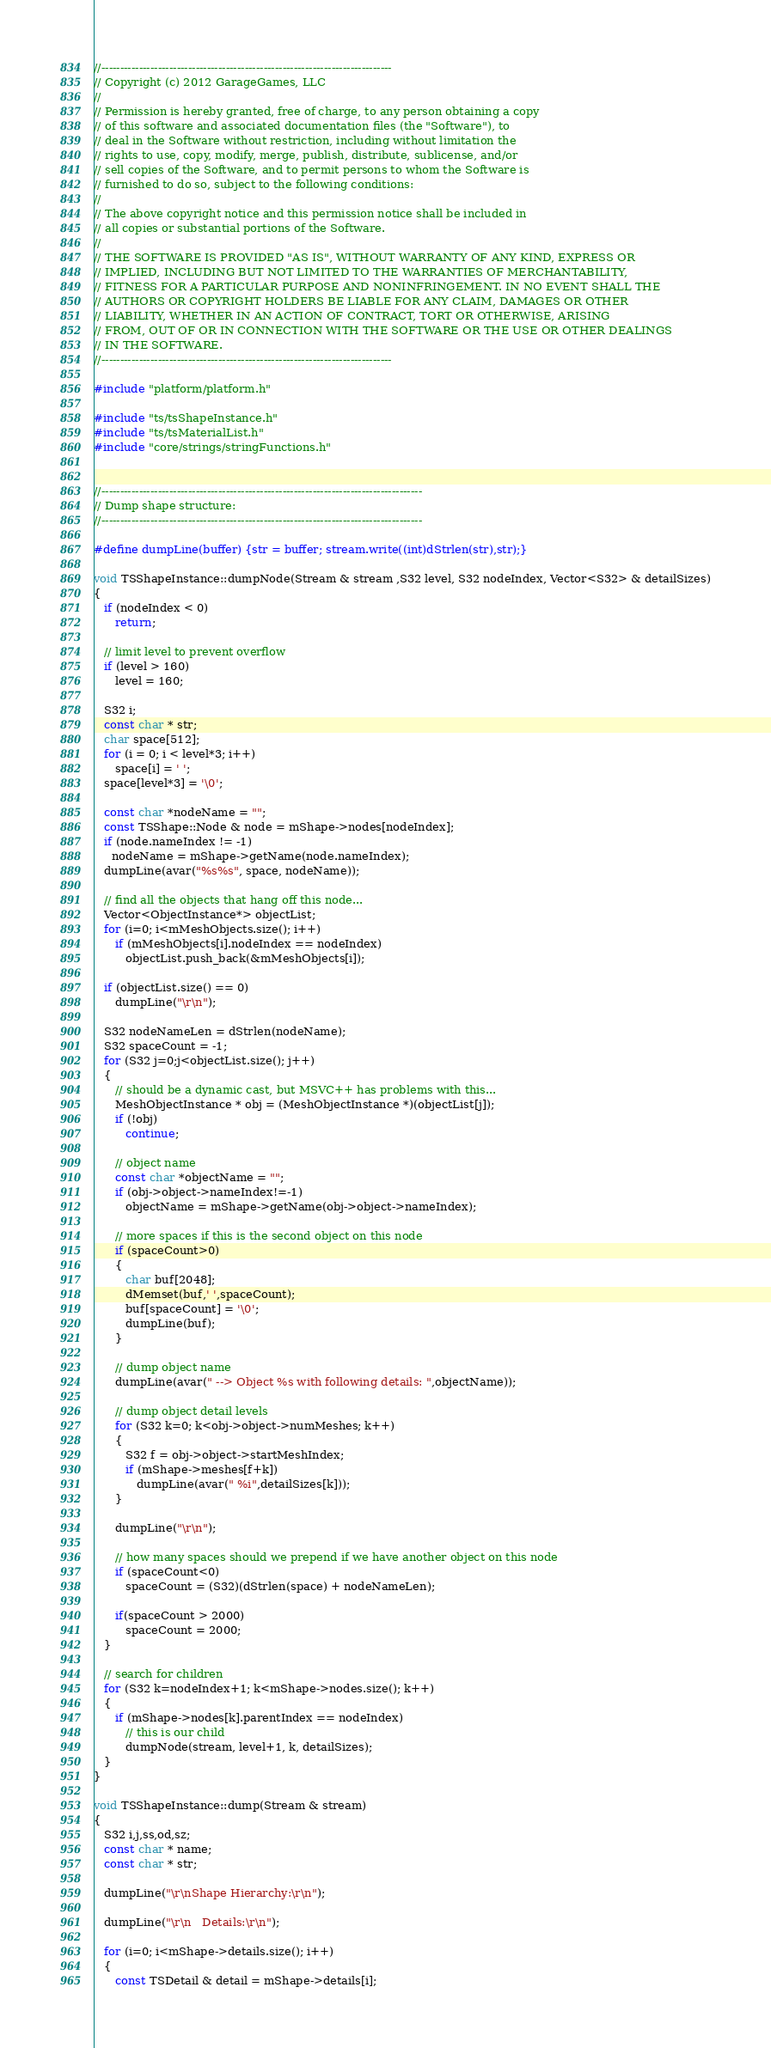<code> <loc_0><loc_0><loc_500><loc_500><_C++_>//-----------------------------------------------------------------------------
// Copyright (c) 2012 GarageGames, LLC
//
// Permission is hereby granted, free of charge, to any person obtaining a copy
// of this software and associated documentation files (the "Software"), to
// deal in the Software without restriction, including without limitation the
// rights to use, copy, modify, merge, publish, distribute, sublicense, and/or
// sell copies of the Software, and to permit persons to whom the Software is
// furnished to do so, subject to the following conditions:
//
// The above copyright notice and this permission notice shall be included in
// all copies or substantial portions of the Software.
//
// THE SOFTWARE IS PROVIDED "AS IS", WITHOUT WARRANTY OF ANY KIND, EXPRESS OR
// IMPLIED, INCLUDING BUT NOT LIMITED TO THE WARRANTIES OF MERCHANTABILITY,
// FITNESS FOR A PARTICULAR PURPOSE AND NONINFRINGEMENT. IN NO EVENT SHALL THE
// AUTHORS OR COPYRIGHT HOLDERS BE LIABLE FOR ANY CLAIM, DAMAGES OR OTHER
// LIABILITY, WHETHER IN AN ACTION OF CONTRACT, TORT OR OTHERWISE, ARISING
// FROM, OUT OF OR IN CONNECTION WITH THE SOFTWARE OR THE USE OR OTHER DEALINGS
// IN THE SOFTWARE.
//-----------------------------------------------------------------------------

#include "platform/platform.h"

#include "ts/tsShapeInstance.h"
#include "ts/tsMaterialList.h"
#include "core/strings/stringFunctions.h"


//-------------------------------------------------------------------------------------
// Dump shape structure:
//-------------------------------------------------------------------------------------

#define dumpLine(buffer) {str = buffer; stream.write((int)dStrlen(str),str);}

void TSShapeInstance::dumpNode(Stream & stream ,S32 level, S32 nodeIndex, Vector<S32> & detailSizes)
{
   if (nodeIndex < 0)
      return;

   // limit level to prevent overflow
   if (level > 160)
      level = 160;

   S32 i;
   const char * str;
   char space[512];
   for (i = 0; i < level*3; i++)
      space[i] = ' ';
   space[level*3] = '\0';

   const char *nodeName = "";
   const TSShape::Node & node = mShape->nodes[nodeIndex];
   if (node.nameIndex != -1)
     nodeName = mShape->getName(node.nameIndex);
   dumpLine(avar("%s%s", space, nodeName));

   // find all the objects that hang off this node...
   Vector<ObjectInstance*> objectList;
   for (i=0; i<mMeshObjects.size(); i++)
      if (mMeshObjects[i].nodeIndex == nodeIndex)
         objectList.push_back(&mMeshObjects[i]);

   if (objectList.size() == 0)
      dumpLine("\r\n");

   S32 nodeNameLen = dStrlen(nodeName);
   S32 spaceCount = -1;
   for (S32 j=0;j<objectList.size(); j++)
   {
      // should be a dynamic cast, but MSVC++ has problems with this...
      MeshObjectInstance * obj = (MeshObjectInstance *)(objectList[j]);
      if (!obj)
         continue;

      // object name
      const char *objectName = "";
      if (obj->object->nameIndex!=-1)
         objectName = mShape->getName(obj->object->nameIndex);

      // more spaces if this is the second object on this node
      if (spaceCount>0)
      {
         char buf[2048];
         dMemset(buf,' ',spaceCount);
         buf[spaceCount] = '\0';
         dumpLine(buf);
      }

      // dump object name
      dumpLine(avar(" --> Object %s with following details: ",objectName));

      // dump object detail levels
      for (S32 k=0; k<obj->object->numMeshes; k++)
      {
         S32 f = obj->object->startMeshIndex;
         if (mShape->meshes[f+k])
            dumpLine(avar(" %i",detailSizes[k]));
      }

      dumpLine("\r\n");

      // how many spaces should we prepend if we have another object on this node
      if (spaceCount<0)
         spaceCount = (S32)(dStrlen(space) + nodeNameLen);

      if(spaceCount > 2000)
         spaceCount = 2000;
   }

   // search for children
   for (S32 k=nodeIndex+1; k<mShape->nodes.size(); k++)
   {
      if (mShape->nodes[k].parentIndex == nodeIndex)
         // this is our child
         dumpNode(stream, level+1, k, detailSizes);
   }
}

void TSShapeInstance::dump(Stream & stream)
{
   S32 i,j,ss,od,sz;
   const char * name;
   const char * str;

   dumpLine("\r\nShape Hierarchy:\r\n");

   dumpLine("\r\n   Details:\r\n");

   for (i=0; i<mShape->details.size(); i++)
   {
      const TSDetail & detail = mShape->details[i];</code> 